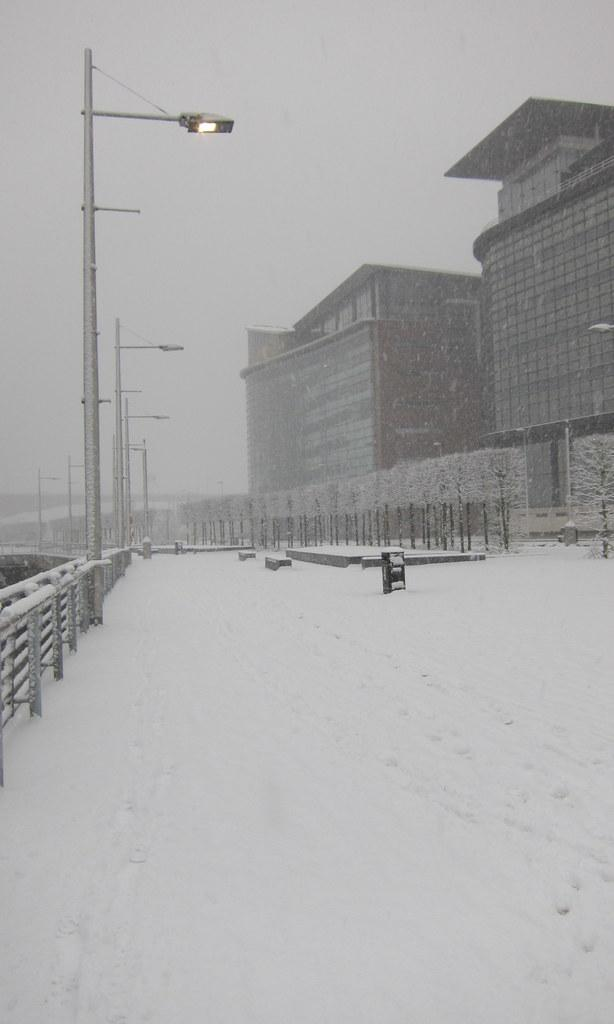What type of lighting can be seen in the image? There are street lights in the image. What can be used for support or safety in the image? There is railing in the image. What weather condition is depicted in the image? There is snow in the image. What type of vegetation is present in the image? There are plants in the image. What type of structures are visible in the image? There are buildings in the image. What other objects can be seen in the image besides the ones mentioned? There are other objects in the image. What is visible in the background of the image? The sky is visible in the background of the image. How much sugar is present in the image? There is no sugar present in the image. What type of stem can be seen growing from the plants in the image? The provided facts do not mention any specific type of stem growing from the plants in the image. 